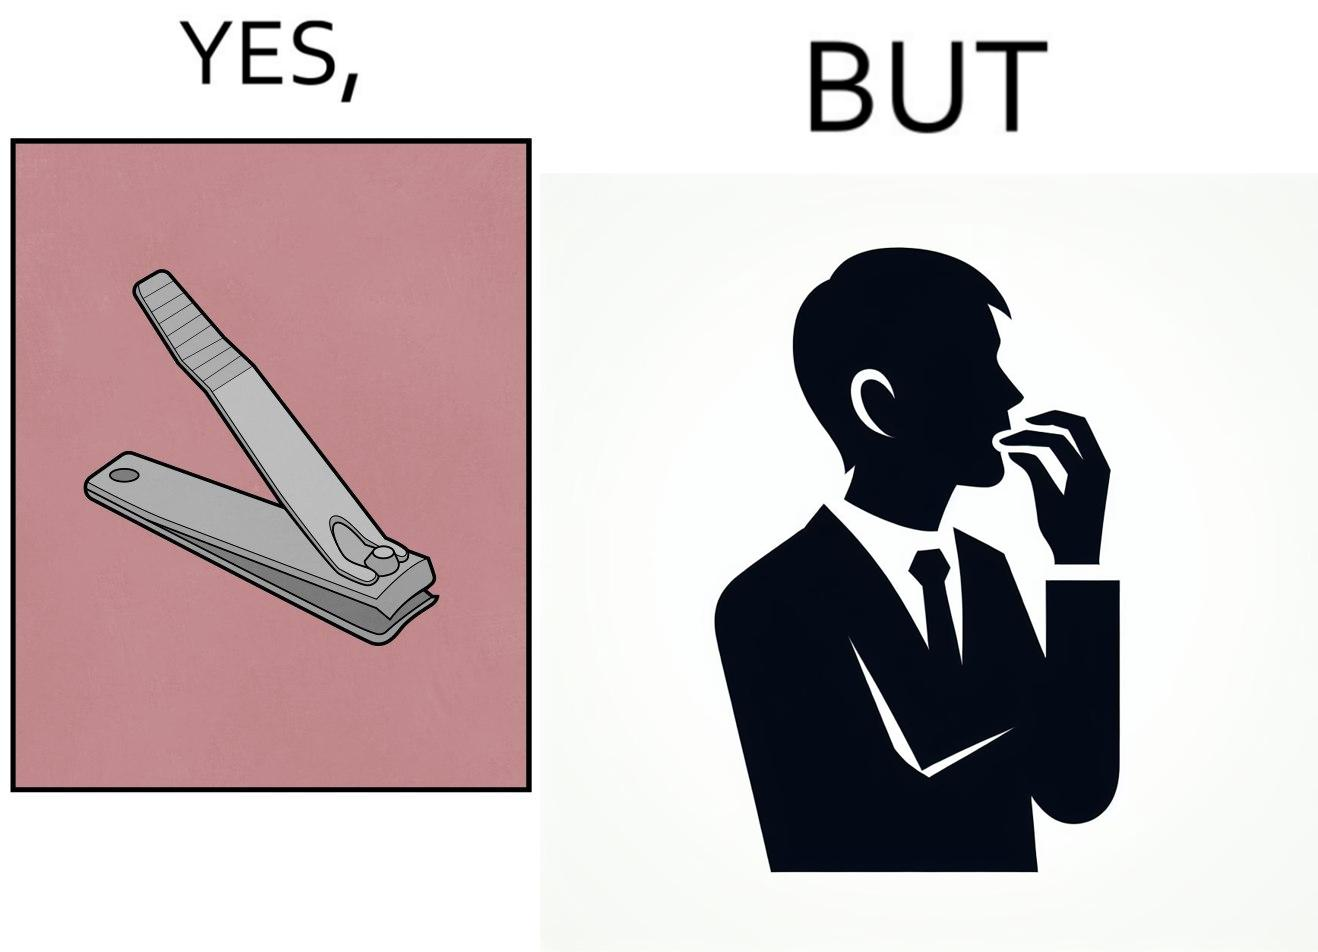Explain why this image is satirical. The image is ironic, because even after nail clippers are available people prefer biting their nails by teeth 